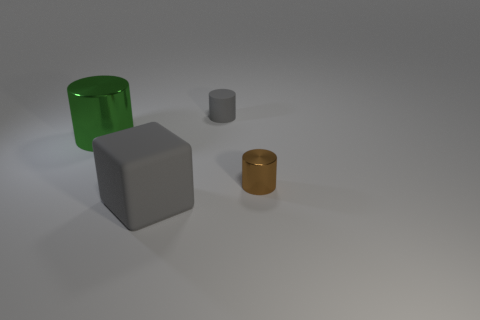What materials do the objects in the image appear to be made from? The objects in the image seem to be made of different materials. The small cylinder and the cube have a metallic sheen, suggesting they could be made of metal, while the taller cylinder has a translucent appearance, which might indicate it is made of glass or plastic. 